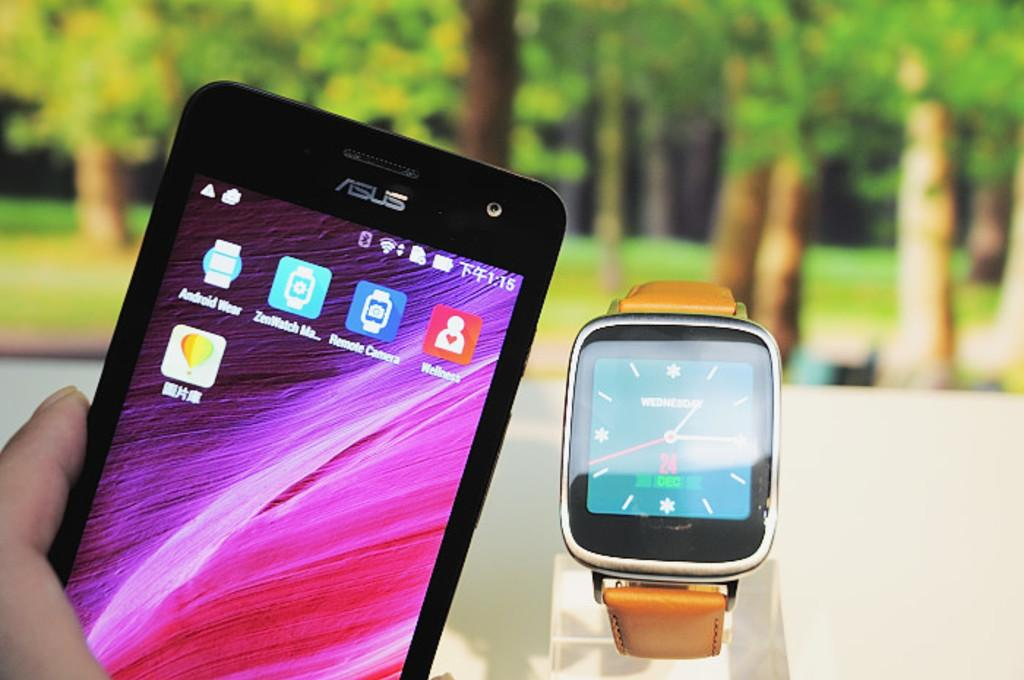<image>
Summarize the visual content of the image. A watch and a phone that shows the time as 1:15 are in front of a nature backdrop. 